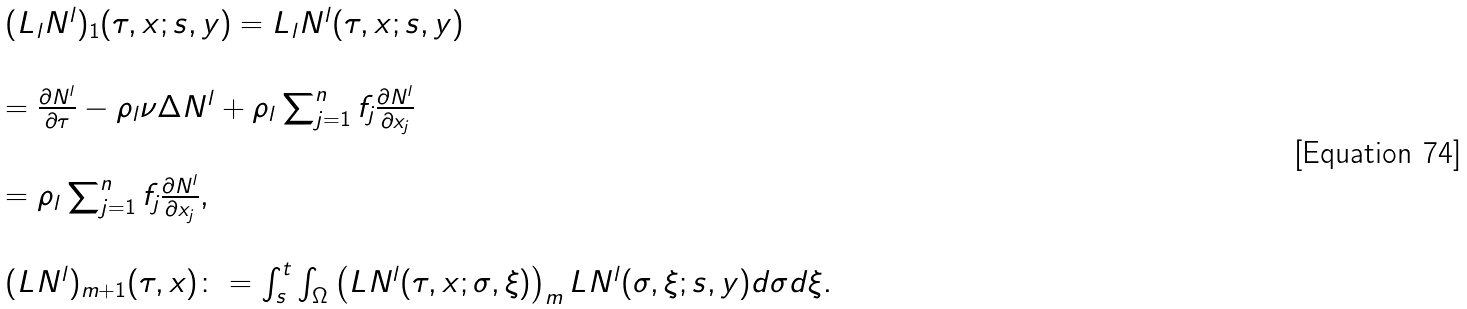Convert formula to latex. <formula><loc_0><loc_0><loc_500><loc_500>\begin{array} { l l } ( L _ { l } N ^ { l } ) _ { 1 } ( \tau , x ; s , y ) = L _ { l } N ^ { l } ( \tau , x ; s , y ) \\ \\ = \frac { \partial N ^ { l } } { \partial \tau } - \rho _ { l } \nu \Delta N ^ { l } + \rho _ { l } \sum _ { j = 1 } ^ { n } f _ { j } \frac { \partial N ^ { l } } { \partial x _ { j } } \\ \\ = \rho _ { l } \sum _ { j = 1 } ^ { n } f _ { j } \frac { \partial N ^ { l } } { \partial x _ { j } } , \\ \\ ( L N ^ { l } ) _ { m + 1 } ( \tau , x ) \colon = \int _ { s } ^ { t } \int _ { \Omega } \left ( L N ^ { l } ( \tau , x ; \sigma , \xi ) \right ) _ { m } L N ^ { l } ( \sigma , \xi ; s , y ) d \sigma d \xi . \end{array}</formula> 